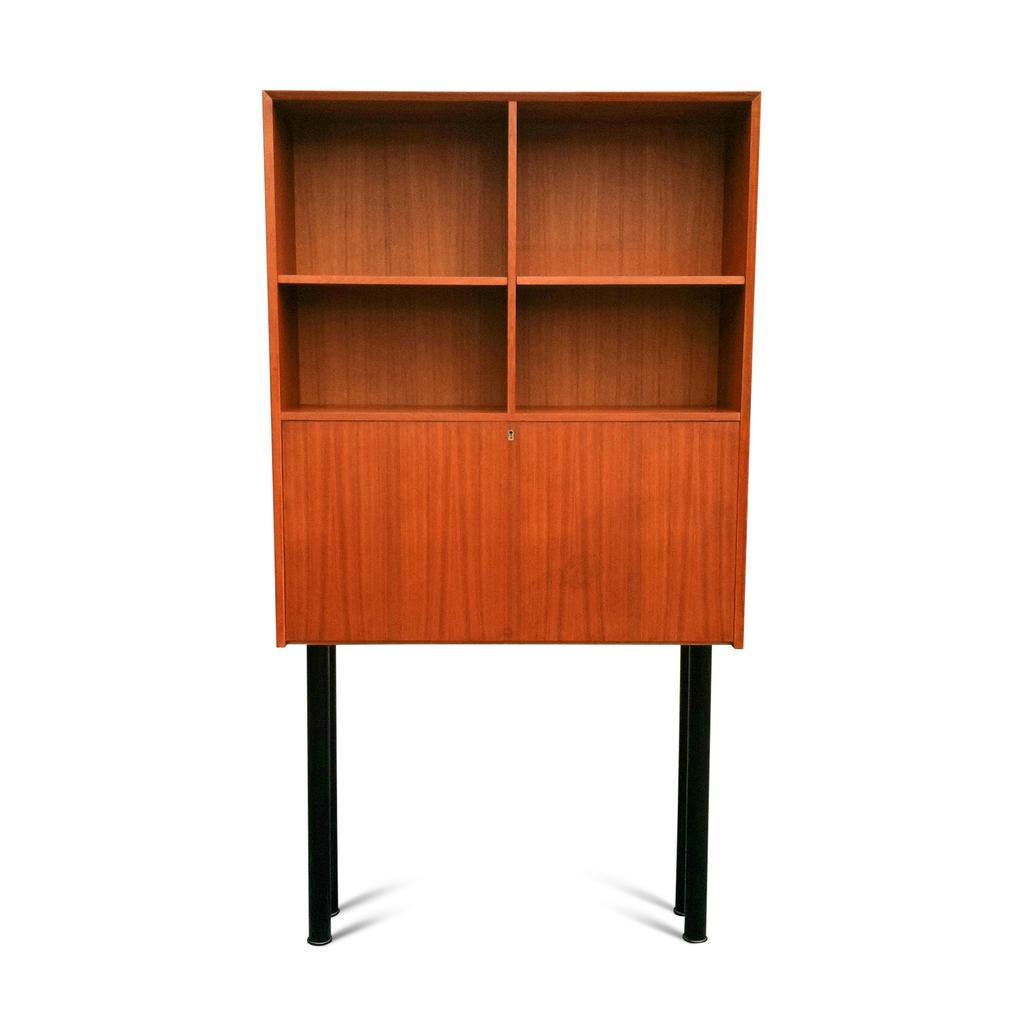Please provide a concise description of this image. In this image I can see 4 black rods on which there is a brown color cupboard. I see that it is totally white color in the background. 